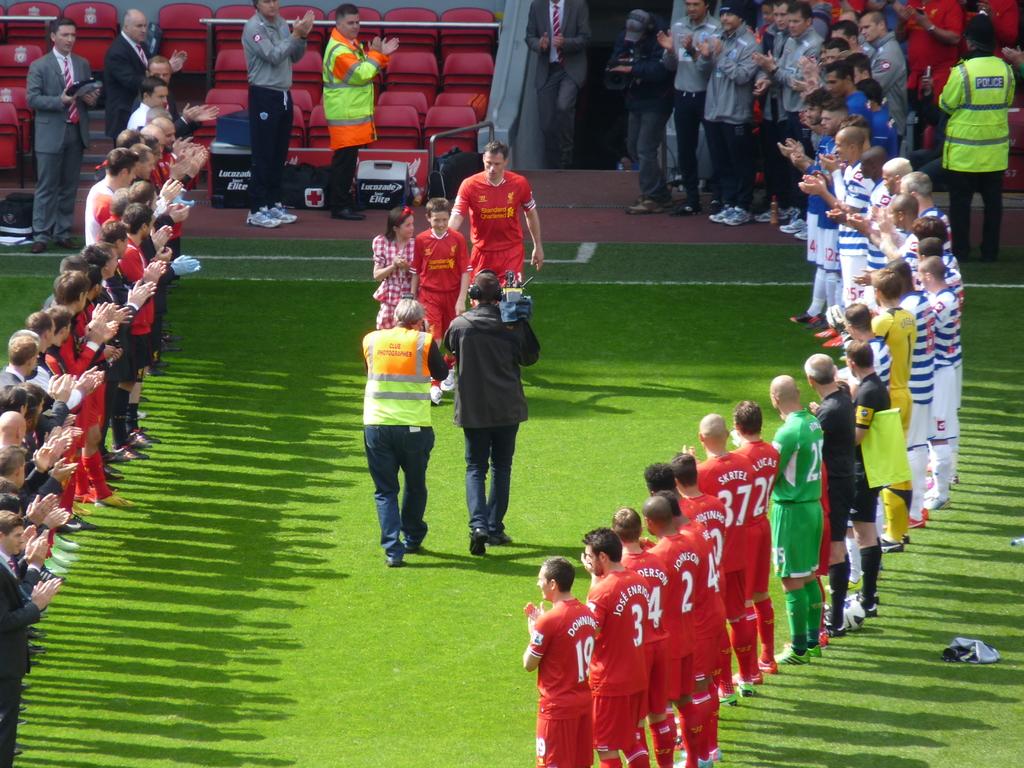What is number 3's first name?
Your response must be concise. Jose. 